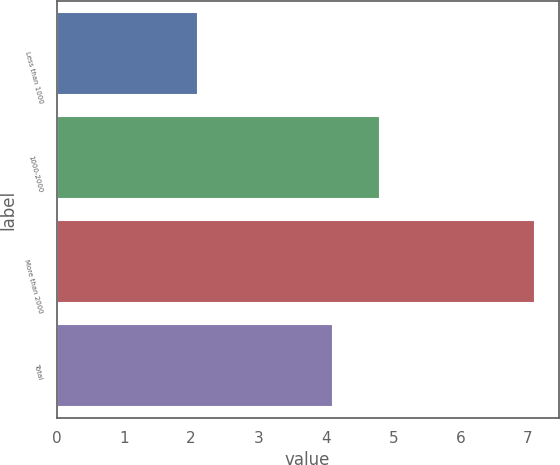Convert chart. <chart><loc_0><loc_0><loc_500><loc_500><bar_chart><fcel>Less than 1000<fcel>1000-2000<fcel>More than 2000<fcel>Total<nl><fcel>2.1<fcel>4.8<fcel>7.1<fcel>4.1<nl></chart> 